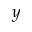Convert formula to latex. <formula><loc_0><loc_0><loc_500><loc_500>y</formula> 